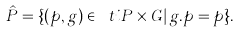Convert formula to latex. <formula><loc_0><loc_0><loc_500><loc_500>\hat { P } = \{ ( p , g ) \in \ t i { P } \times G | \, g . p = p \} .</formula> 